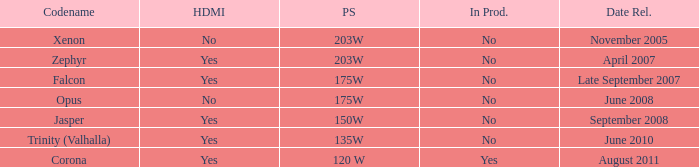Is Jasper being producted? No. 